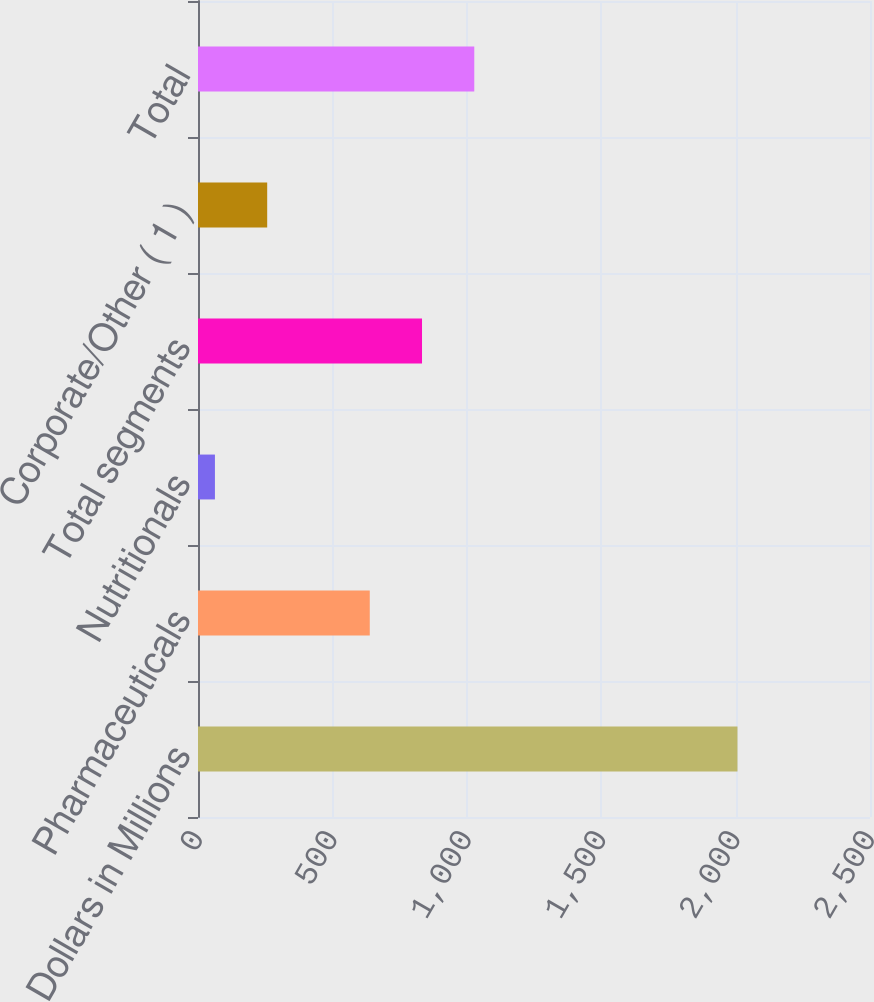Convert chart. <chart><loc_0><loc_0><loc_500><loc_500><bar_chart><fcel>Dollars in Millions<fcel>Pharmaceuticals<fcel>Nutritionals<fcel>Total segments<fcel>Corporate/Other ( 1 )<fcel>Total<nl><fcel>2007<fcel>639<fcel>63<fcel>833.4<fcel>257.4<fcel>1027.8<nl></chart> 